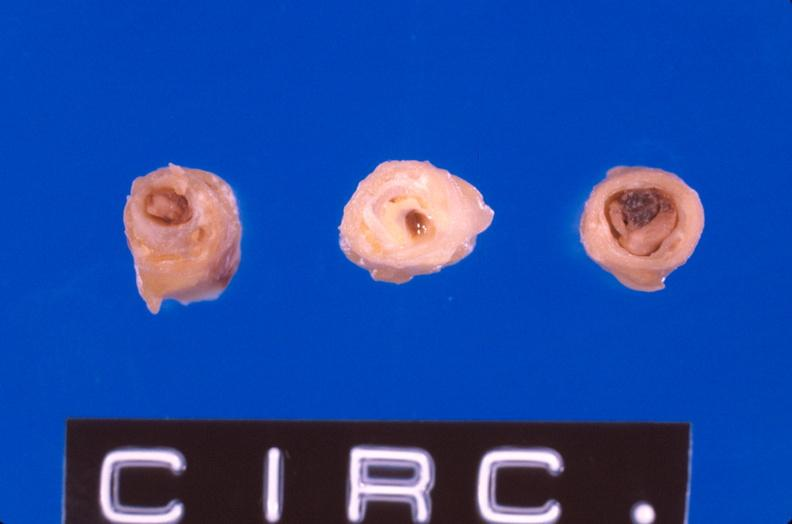what is present?
Answer the question using a single word or phrase. Cardiovascular 